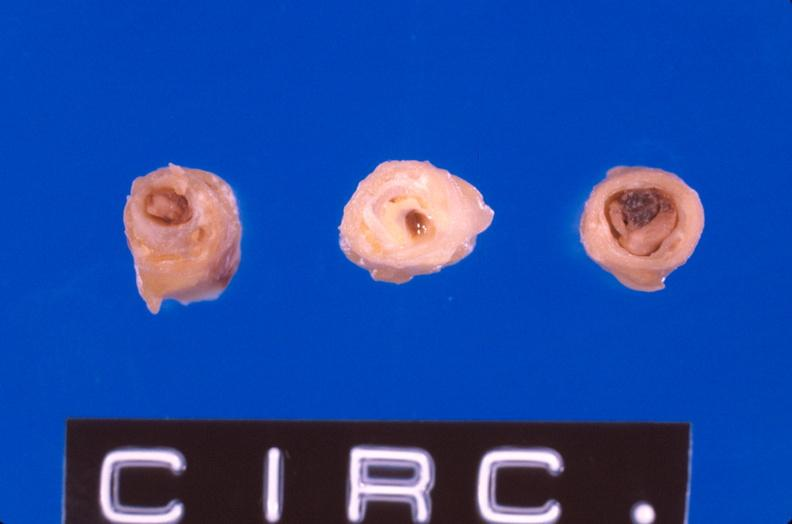what is present?
Answer the question using a single word or phrase. Cardiovascular 